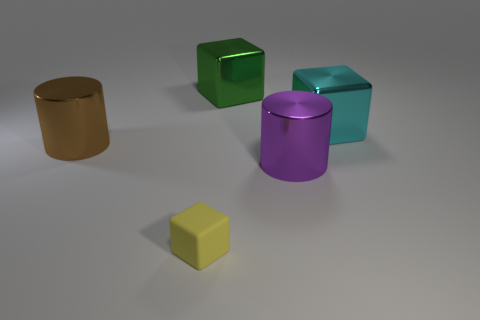Add 5 big shiny cylinders. How many objects exist? 10 Subtract all blocks. How many objects are left? 2 Add 5 cyan metal cubes. How many cyan metal cubes are left? 6 Add 3 big purple things. How many big purple things exist? 4 Subtract 0 gray cylinders. How many objects are left? 5 Subtract all large green things. Subtract all large metallic cubes. How many objects are left? 2 